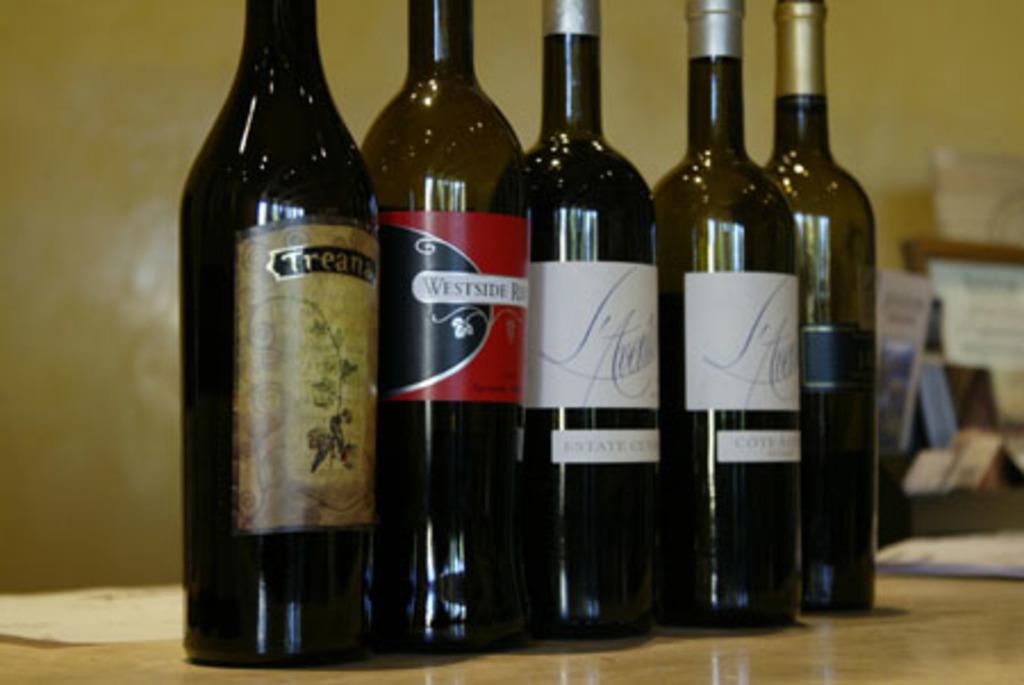What is the first word on the black and red label?
Make the answer very short. Westside. 